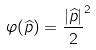Convert formula to latex. <formula><loc_0><loc_0><loc_500><loc_500>\varphi ( \widehat { p } ) = \frac { | \widehat { p } | } { 2 } ^ { 2 }</formula> 